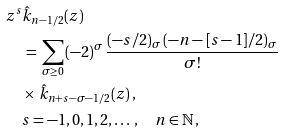Convert formula to latex. <formula><loc_0><loc_0><loc_500><loc_500>& z ^ { s } \hat { k } _ { n - 1 / 2 } ( z ) \\ & \quad \, = \, \sum _ { \sigma \geq 0 } \, ( - 2 ) ^ { \sigma } \, \frac { ( - s / 2 ) _ { \sigma } \, ( - n - [ s - 1 ] / 2 ) _ { \sigma } } { { \sigma } ! } \\ & \quad \times \, \hat { k } _ { n + s - \sigma - 1 / 2 } ( z ) \, , \\ & \quad s = - 1 , 0 , 1 , 2 , \dots \, , \quad n \in \mathbb { N } \, ,</formula> 